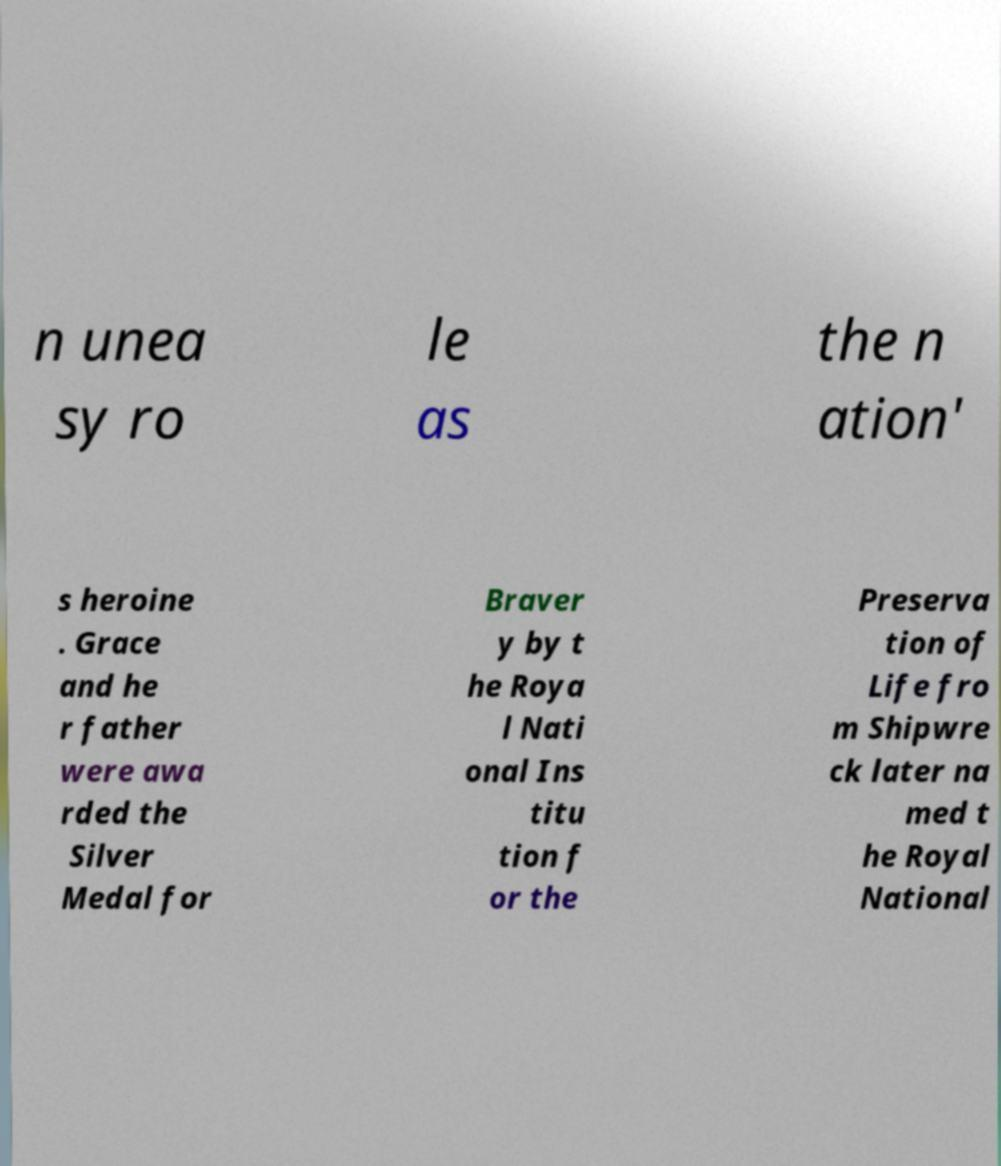Please identify and transcribe the text found in this image. n unea sy ro le as the n ation' s heroine . Grace and he r father were awa rded the Silver Medal for Braver y by t he Roya l Nati onal Ins titu tion f or the Preserva tion of Life fro m Shipwre ck later na med t he Royal National 